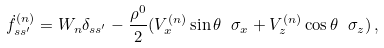Convert formula to latex. <formula><loc_0><loc_0><loc_500><loc_500>\dot { f } _ { s s ^ { \prime } } ^ { ( n ) } = W _ { n } \delta _ { s s ^ { \prime } } - \frac { \rho ^ { 0 } } { 2 } ( V _ { x } ^ { ( n ) } \sin { \theta } \ \sigma _ { x } + V _ { z } ^ { ( n ) } \cos { \theta } \ \sigma _ { z } ) \, ,</formula> 